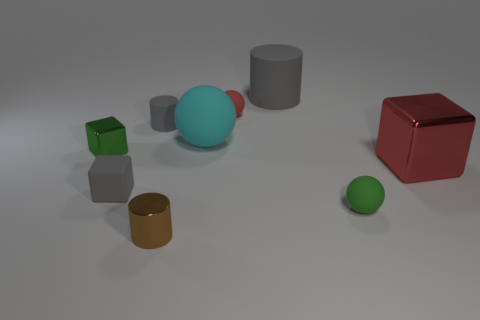How many other things are the same color as the big matte cylinder? Besides the big matte cylinder, there are two small objects that share the same color: a small sphere and a small cube. 